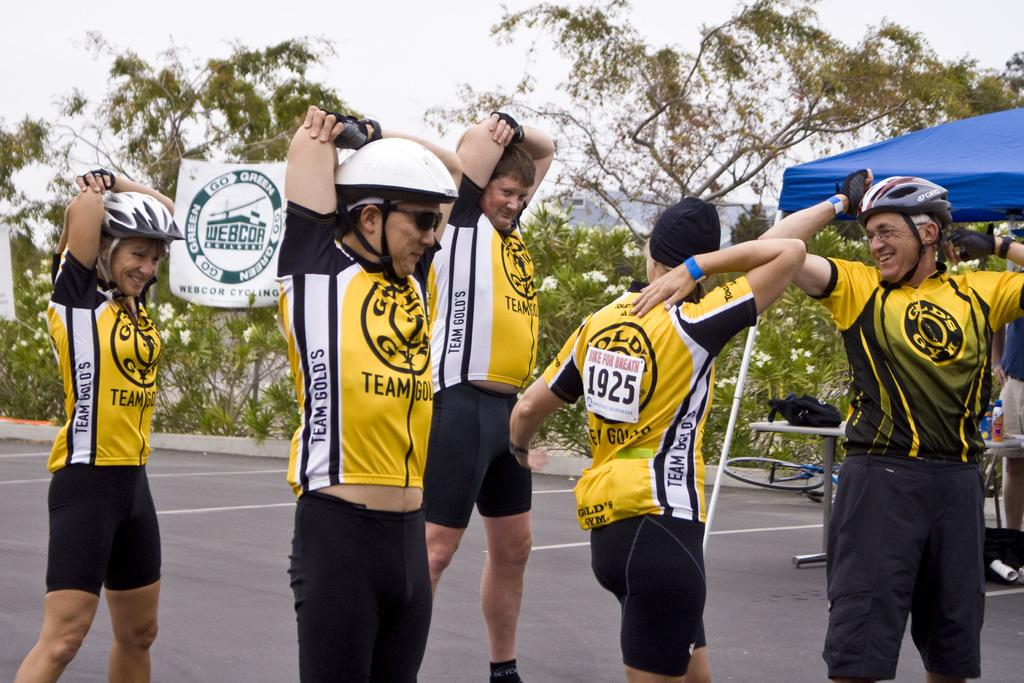<image>
Write a terse but informative summary of the picture. The bikers of Team Gold's are stretching before the bike race. 